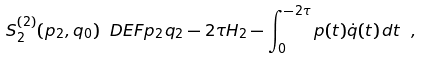<formula> <loc_0><loc_0><loc_500><loc_500>S _ { 2 } ^ { ( 2 ) } ( p _ { 2 } , q _ { 0 } ) \ D E F p _ { 2 } q _ { 2 } - 2 \tau H _ { 2 } - \int _ { 0 } ^ { - 2 \tau } p ( t ) \dot { q } ( t ) \, d t \ ,</formula> 